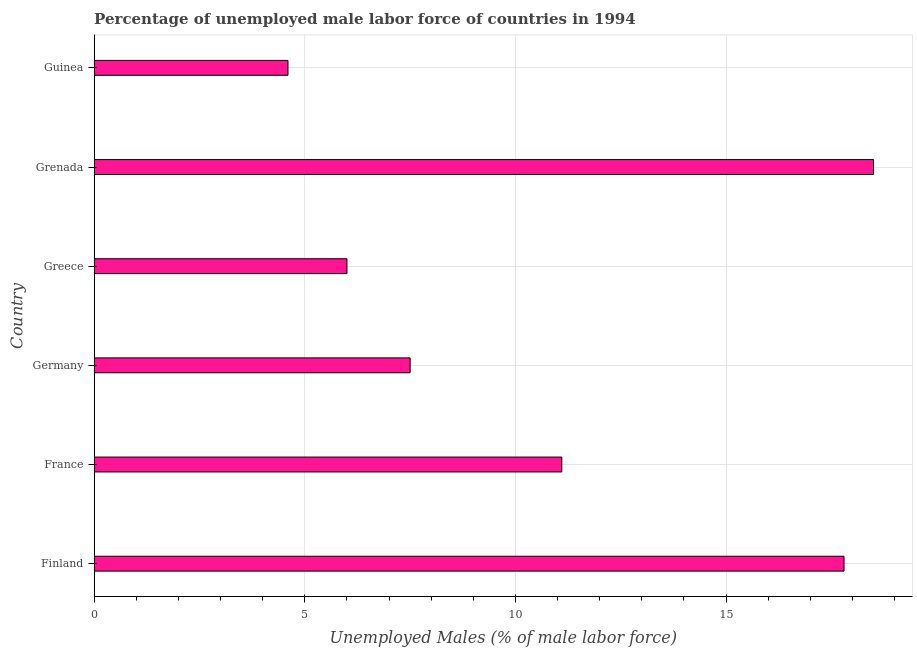Does the graph contain any zero values?
Offer a very short reply. No. What is the title of the graph?
Keep it short and to the point. Percentage of unemployed male labor force of countries in 1994. What is the label or title of the X-axis?
Offer a terse response. Unemployed Males (% of male labor force). What is the label or title of the Y-axis?
Offer a terse response. Country. What is the total unemployed male labour force in France?
Give a very brief answer. 11.1. Across all countries, what is the minimum total unemployed male labour force?
Make the answer very short. 4.6. In which country was the total unemployed male labour force maximum?
Keep it short and to the point. Grenada. In which country was the total unemployed male labour force minimum?
Your response must be concise. Guinea. What is the sum of the total unemployed male labour force?
Your response must be concise. 65.5. What is the difference between the total unemployed male labour force in Greece and Guinea?
Keep it short and to the point. 1.4. What is the average total unemployed male labour force per country?
Ensure brevity in your answer.  10.92. What is the median total unemployed male labour force?
Your response must be concise. 9.3. In how many countries, is the total unemployed male labour force greater than 1 %?
Make the answer very short. 6. What is the ratio of the total unemployed male labour force in Germany to that in Grenada?
Offer a very short reply. 0.41. Is the total unemployed male labour force in Finland less than that in Guinea?
Offer a very short reply. No. What is the difference between the highest and the second highest total unemployed male labour force?
Provide a succinct answer. 0.7. In how many countries, is the total unemployed male labour force greater than the average total unemployed male labour force taken over all countries?
Provide a succinct answer. 3. How many bars are there?
Your answer should be very brief. 6. What is the difference between two consecutive major ticks on the X-axis?
Your answer should be compact. 5. What is the Unemployed Males (% of male labor force) of Finland?
Your answer should be very brief. 17.8. What is the Unemployed Males (% of male labor force) of France?
Your response must be concise. 11.1. What is the Unemployed Males (% of male labor force) of Greece?
Make the answer very short. 6. What is the Unemployed Males (% of male labor force) of Guinea?
Give a very brief answer. 4.6. What is the difference between the Unemployed Males (% of male labor force) in Finland and Guinea?
Your response must be concise. 13.2. What is the difference between the Unemployed Males (% of male labor force) in France and Germany?
Your answer should be very brief. 3.6. What is the difference between the Unemployed Males (% of male labor force) in France and Greece?
Give a very brief answer. 5.1. What is the ratio of the Unemployed Males (% of male labor force) in Finland to that in France?
Give a very brief answer. 1.6. What is the ratio of the Unemployed Males (% of male labor force) in Finland to that in Germany?
Make the answer very short. 2.37. What is the ratio of the Unemployed Males (% of male labor force) in Finland to that in Greece?
Offer a terse response. 2.97. What is the ratio of the Unemployed Males (% of male labor force) in Finland to that in Grenada?
Give a very brief answer. 0.96. What is the ratio of the Unemployed Males (% of male labor force) in Finland to that in Guinea?
Provide a succinct answer. 3.87. What is the ratio of the Unemployed Males (% of male labor force) in France to that in Germany?
Offer a very short reply. 1.48. What is the ratio of the Unemployed Males (% of male labor force) in France to that in Greece?
Give a very brief answer. 1.85. What is the ratio of the Unemployed Males (% of male labor force) in France to that in Grenada?
Ensure brevity in your answer.  0.6. What is the ratio of the Unemployed Males (% of male labor force) in France to that in Guinea?
Your answer should be very brief. 2.41. What is the ratio of the Unemployed Males (% of male labor force) in Germany to that in Grenada?
Provide a short and direct response. 0.41. What is the ratio of the Unemployed Males (% of male labor force) in Germany to that in Guinea?
Give a very brief answer. 1.63. What is the ratio of the Unemployed Males (% of male labor force) in Greece to that in Grenada?
Your answer should be compact. 0.32. What is the ratio of the Unemployed Males (% of male labor force) in Greece to that in Guinea?
Provide a succinct answer. 1.3. What is the ratio of the Unemployed Males (% of male labor force) in Grenada to that in Guinea?
Offer a very short reply. 4.02. 